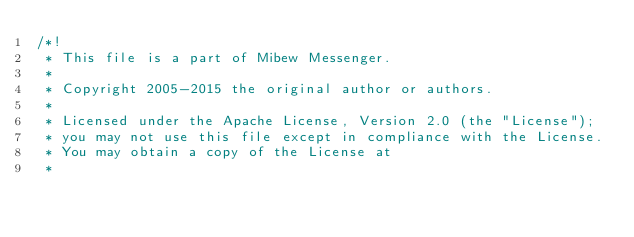<code> <loc_0><loc_0><loc_500><loc_500><_JavaScript_>/*!
 * This file is a part of Mibew Messenger.
 *
 * Copyright 2005-2015 the original author or authors.
 *
 * Licensed under the Apache License, Version 2.0 (the "License");
 * you may not use this file except in compliance with the License.
 * You may obtain a copy of the License at
 *</code> 